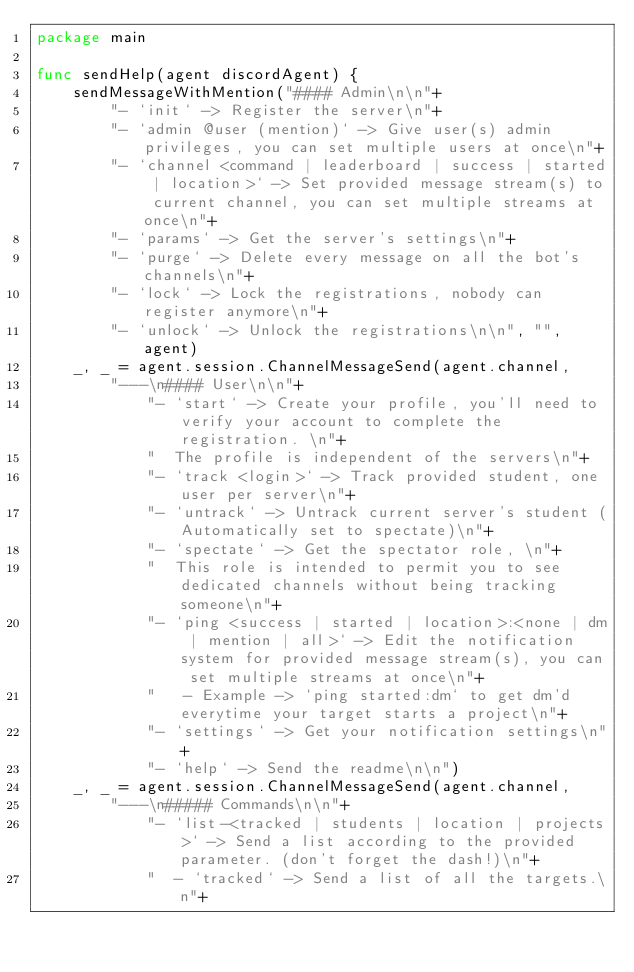<code> <loc_0><loc_0><loc_500><loc_500><_Go_>package main

func sendHelp(agent discordAgent) {
	sendMessageWithMention("#### Admin\n\n"+
		"- `init` -> Register the server\n"+
		"- `admin @user (mention)` -> Give user(s) admin privileges, you can set multiple users at once\n"+
		"- `channel <command | leaderboard | success | started | location>` -> Set provided message stream(s) to current channel, you can set multiple streams at once\n"+
		"- `params` -> Get the server's settings\n"+
		"- `purge` -> Delete every message on all the bot's channels\n"+
		"- `lock` -> Lock the registrations, nobody can register anymore\n"+
		"- `unlock` -> Unlock the registrations\n\n", "", agent)
	_, _ = agent.session.ChannelMessageSend(agent.channel,
		"---\n#### User\n\n"+
			"- `start` -> Create your profile, you'll need to verify your account to complete the registration. \n"+
			"  The profile is independent of the servers\n"+
			"- `track <login>` -> Track provided student, one user per server\n"+
			"- `untrack` -> Untrack current server's student (Automatically set to spectate)\n"+
			"- `spectate` -> Get the spectator role, \n"+
			"  This role is intended to permit you to see dedicated channels without being tracking someone\n"+
			"- `ping <success | started | location>:<none | dm | mention | all>` -> Edit the notification system for provided message stream(s), you can set multiple streams at once\n"+
			"   - Example -> `ping started:dm` to get dm'd everytime your target starts a project\n"+
			"- `settings` -> Get your notification settings\n"+
			"- `help` -> Send the readme\n\n")
	_, _ = agent.session.ChannelMessageSend(agent.channel,
		"---\n##### Commands\n\n"+
			"- `list-<tracked | students | location | projects>` -> Send a list according to the provided parameter. (don't forget the dash!)\n"+
			"  - `tracked` -> Send a list of all the targets.\n"+</code> 